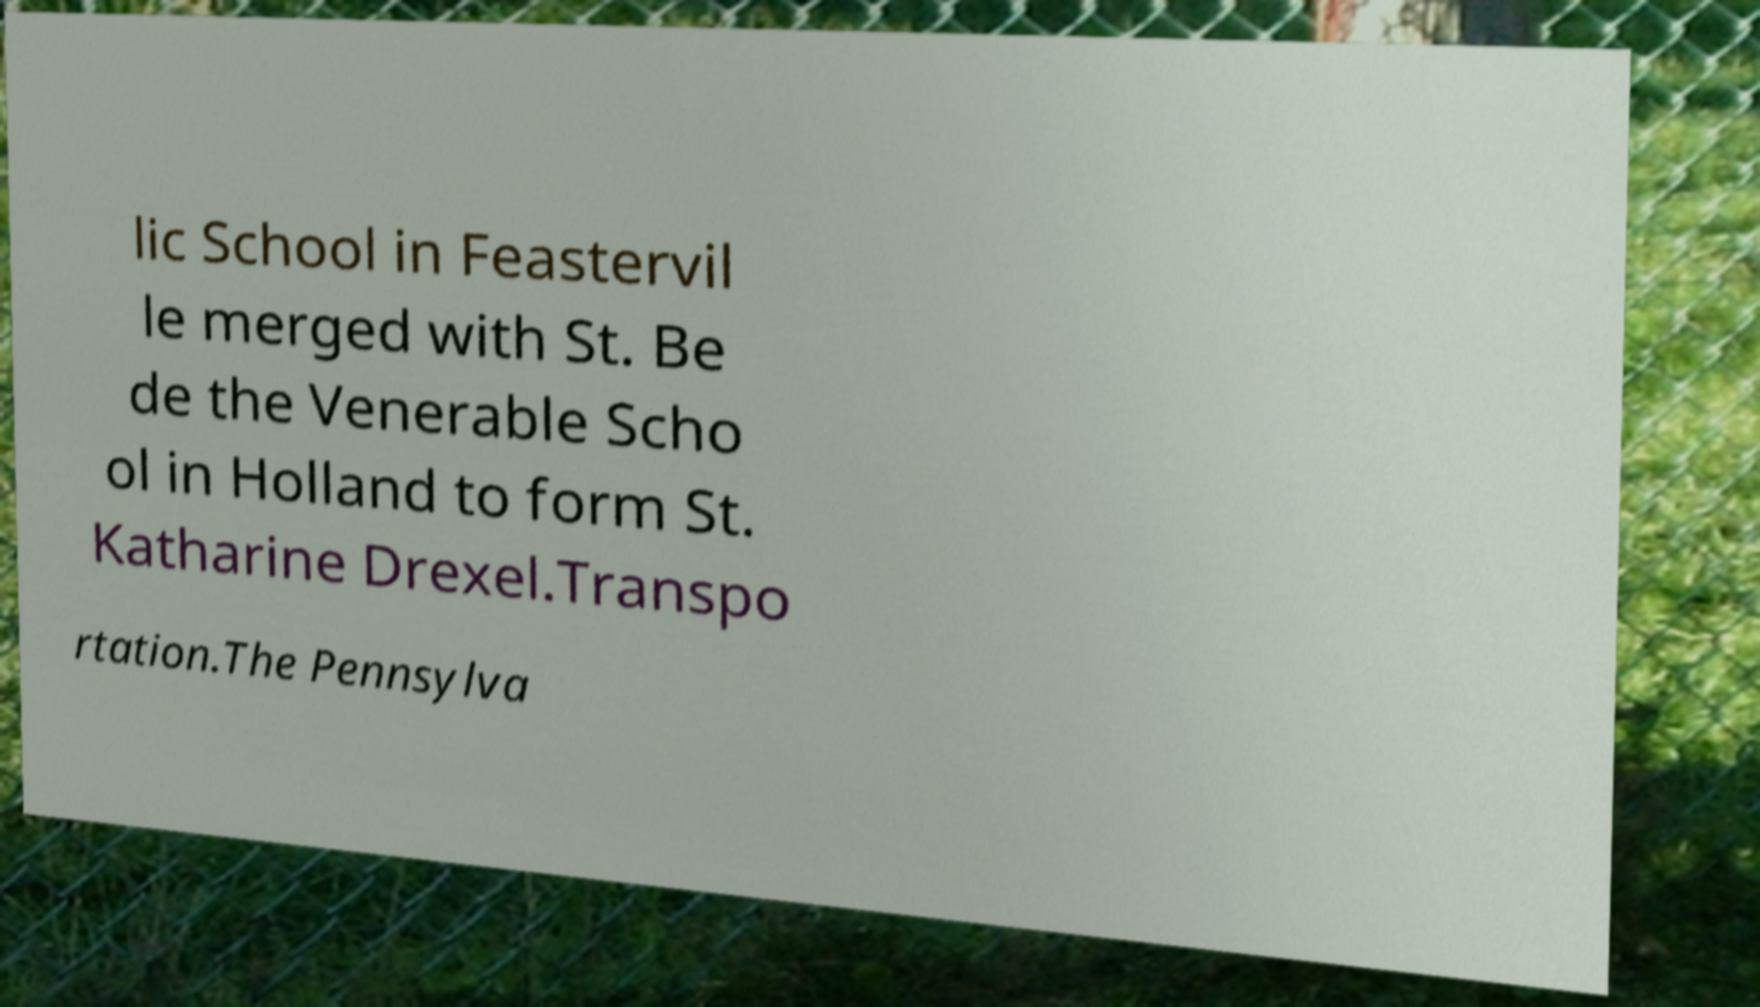Can you accurately transcribe the text from the provided image for me? lic School in Feastervil le merged with St. Be de the Venerable Scho ol in Holland to form St. Katharine Drexel.Transpo rtation.The Pennsylva 